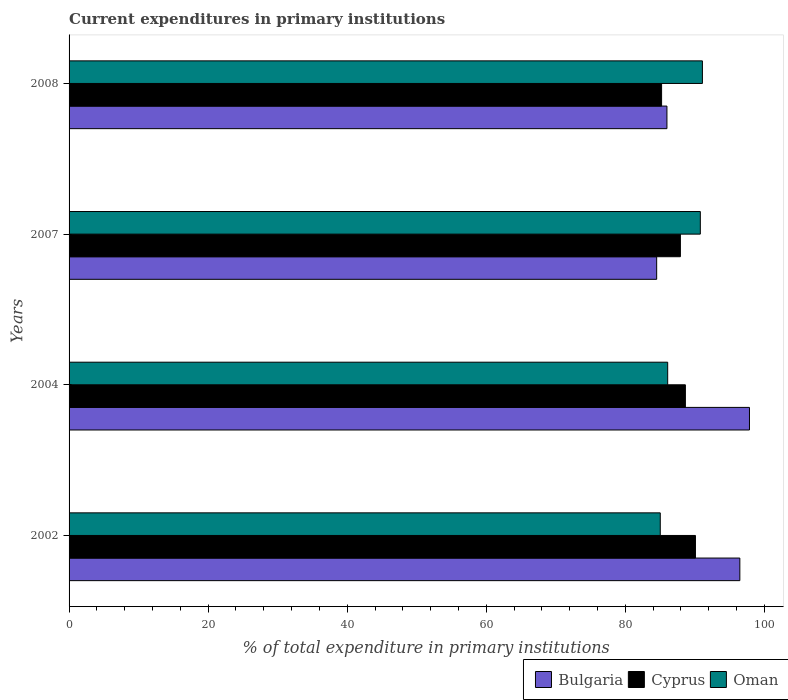How many groups of bars are there?
Your response must be concise. 4. Are the number of bars per tick equal to the number of legend labels?
Your answer should be very brief. Yes. What is the current expenditures in primary institutions in Bulgaria in 2007?
Provide a succinct answer. 84.51. Across all years, what is the maximum current expenditures in primary institutions in Bulgaria?
Provide a succinct answer. 97.85. Across all years, what is the minimum current expenditures in primary institutions in Oman?
Keep it short and to the point. 85.02. In which year was the current expenditures in primary institutions in Bulgaria maximum?
Your answer should be compact. 2004. What is the total current expenditures in primary institutions in Oman in the graph?
Give a very brief answer. 352.97. What is the difference between the current expenditures in primary institutions in Oman in 2002 and that in 2007?
Offer a terse response. -5.76. What is the difference between the current expenditures in primary institutions in Bulgaria in 2008 and the current expenditures in primary institutions in Oman in 2007?
Offer a terse response. -4.8. What is the average current expenditures in primary institutions in Bulgaria per year?
Your answer should be compact. 91.2. In the year 2004, what is the difference between the current expenditures in primary institutions in Bulgaria and current expenditures in primary institutions in Oman?
Keep it short and to the point. 11.76. In how many years, is the current expenditures in primary institutions in Oman greater than 12 %?
Provide a succinct answer. 4. What is the ratio of the current expenditures in primary institutions in Oman in 2002 to that in 2008?
Make the answer very short. 0.93. What is the difference between the highest and the second highest current expenditures in primary institutions in Cyprus?
Your answer should be compact. 1.45. What is the difference between the highest and the lowest current expenditures in primary institutions in Oman?
Your answer should be compact. 6.06. In how many years, is the current expenditures in primary institutions in Cyprus greater than the average current expenditures in primary institutions in Cyprus taken over all years?
Keep it short and to the point. 2. Is the sum of the current expenditures in primary institutions in Cyprus in 2004 and 2007 greater than the maximum current expenditures in primary institutions in Oman across all years?
Your answer should be compact. Yes. What does the 1st bar from the top in 2004 represents?
Offer a terse response. Oman. What does the 2nd bar from the bottom in 2008 represents?
Provide a succinct answer. Cyprus. Are all the bars in the graph horizontal?
Make the answer very short. Yes. How many years are there in the graph?
Make the answer very short. 4. Does the graph contain grids?
Provide a short and direct response. No. Where does the legend appear in the graph?
Ensure brevity in your answer.  Bottom right. How many legend labels are there?
Give a very brief answer. 3. What is the title of the graph?
Provide a short and direct response. Current expenditures in primary institutions. Does "Portugal" appear as one of the legend labels in the graph?
Offer a terse response. No. What is the label or title of the X-axis?
Keep it short and to the point. % of total expenditure in primary institutions. What is the label or title of the Y-axis?
Give a very brief answer. Years. What is the % of total expenditure in primary institutions of Bulgaria in 2002?
Your answer should be very brief. 96.47. What is the % of total expenditure in primary institutions in Cyprus in 2002?
Provide a short and direct response. 90.08. What is the % of total expenditure in primary institutions of Oman in 2002?
Ensure brevity in your answer.  85.02. What is the % of total expenditure in primary institutions of Bulgaria in 2004?
Ensure brevity in your answer.  97.85. What is the % of total expenditure in primary institutions of Cyprus in 2004?
Offer a terse response. 88.63. What is the % of total expenditure in primary institutions in Oman in 2004?
Make the answer very short. 86.09. What is the % of total expenditure in primary institutions in Bulgaria in 2007?
Your response must be concise. 84.51. What is the % of total expenditure in primary institutions of Cyprus in 2007?
Provide a succinct answer. 87.92. What is the % of total expenditure in primary institutions in Oman in 2007?
Make the answer very short. 90.78. What is the % of total expenditure in primary institutions of Bulgaria in 2008?
Your answer should be very brief. 85.98. What is the % of total expenditure in primary institutions of Cyprus in 2008?
Your response must be concise. 85.21. What is the % of total expenditure in primary institutions of Oman in 2008?
Ensure brevity in your answer.  91.08. Across all years, what is the maximum % of total expenditure in primary institutions in Bulgaria?
Give a very brief answer. 97.85. Across all years, what is the maximum % of total expenditure in primary institutions of Cyprus?
Ensure brevity in your answer.  90.08. Across all years, what is the maximum % of total expenditure in primary institutions in Oman?
Keep it short and to the point. 91.08. Across all years, what is the minimum % of total expenditure in primary institutions of Bulgaria?
Offer a very short reply. 84.51. Across all years, what is the minimum % of total expenditure in primary institutions of Cyprus?
Your answer should be very brief. 85.21. Across all years, what is the minimum % of total expenditure in primary institutions of Oman?
Your answer should be compact. 85.02. What is the total % of total expenditure in primary institutions of Bulgaria in the graph?
Give a very brief answer. 364.8. What is the total % of total expenditure in primary institutions of Cyprus in the graph?
Your answer should be compact. 351.85. What is the total % of total expenditure in primary institutions in Oman in the graph?
Make the answer very short. 352.97. What is the difference between the % of total expenditure in primary institutions in Bulgaria in 2002 and that in 2004?
Keep it short and to the point. -1.38. What is the difference between the % of total expenditure in primary institutions in Cyprus in 2002 and that in 2004?
Provide a short and direct response. 1.45. What is the difference between the % of total expenditure in primary institutions of Oman in 2002 and that in 2004?
Offer a terse response. -1.07. What is the difference between the % of total expenditure in primary institutions in Bulgaria in 2002 and that in 2007?
Make the answer very short. 11.96. What is the difference between the % of total expenditure in primary institutions in Cyprus in 2002 and that in 2007?
Provide a succinct answer. 2.17. What is the difference between the % of total expenditure in primary institutions in Oman in 2002 and that in 2007?
Keep it short and to the point. -5.76. What is the difference between the % of total expenditure in primary institutions in Bulgaria in 2002 and that in 2008?
Your answer should be very brief. 10.49. What is the difference between the % of total expenditure in primary institutions of Cyprus in 2002 and that in 2008?
Keep it short and to the point. 4.87. What is the difference between the % of total expenditure in primary institutions of Oman in 2002 and that in 2008?
Ensure brevity in your answer.  -6.06. What is the difference between the % of total expenditure in primary institutions in Bulgaria in 2004 and that in 2007?
Provide a short and direct response. 13.35. What is the difference between the % of total expenditure in primary institutions of Cyprus in 2004 and that in 2007?
Provide a succinct answer. 0.72. What is the difference between the % of total expenditure in primary institutions of Oman in 2004 and that in 2007?
Provide a short and direct response. -4.69. What is the difference between the % of total expenditure in primary institutions of Bulgaria in 2004 and that in 2008?
Provide a succinct answer. 11.87. What is the difference between the % of total expenditure in primary institutions of Cyprus in 2004 and that in 2008?
Ensure brevity in your answer.  3.42. What is the difference between the % of total expenditure in primary institutions in Oman in 2004 and that in 2008?
Your answer should be very brief. -4.99. What is the difference between the % of total expenditure in primary institutions in Bulgaria in 2007 and that in 2008?
Provide a succinct answer. -1.48. What is the difference between the % of total expenditure in primary institutions of Cyprus in 2007 and that in 2008?
Provide a succinct answer. 2.7. What is the difference between the % of total expenditure in primary institutions in Oman in 2007 and that in 2008?
Offer a terse response. -0.3. What is the difference between the % of total expenditure in primary institutions of Bulgaria in 2002 and the % of total expenditure in primary institutions of Cyprus in 2004?
Provide a short and direct response. 7.83. What is the difference between the % of total expenditure in primary institutions of Bulgaria in 2002 and the % of total expenditure in primary institutions of Oman in 2004?
Your answer should be compact. 10.38. What is the difference between the % of total expenditure in primary institutions of Cyprus in 2002 and the % of total expenditure in primary institutions of Oman in 2004?
Give a very brief answer. 3.99. What is the difference between the % of total expenditure in primary institutions in Bulgaria in 2002 and the % of total expenditure in primary institutions in Cyprus in 2007?
Provide a short and direct response. 8.55. What is the difference between the % of total expenditure in primary institutions in Bulgaria in 2002 and the % of total expenditure in primary institutions in Oman in 2007?
Your answer should be compact. 5.68. What is the difference between the % of total expenditure in primary institutions in Cyprus in 2002 and the % of total expenditure in primary institutions in Oman in 2007?
Offer a terse response. -0.7. What is the difference between the % of total expenditure in primary institutions of Bulgaria in 2002 and the % of total expenditure in primary institutions of Cyprus in 2008?
Provide a short and direct response. 11.25. What is the difference between the % of total expenditure in primary institutions in Bulgaria in 2002 and the % of total expenditure in primary institutions in Oman in 2008?
Make the answer very short. 5.38. What is the difference between the % of total expenditure in primary institutions in Cyprus in 2002 and the % of total expenditure in primary institutions in Oman in 2008?
Provide a short and direct response. -1. What is the difference between the % of total expenditure in primary institutions in Bulgaria in 2004 and the % of total expenditure in primary institutions in Cyprus in 2007?
Ensure brevity in your answer.  9.93. What is the difference between the % of total expenditure in primary institutions of Bulgaria in 2004 and the % of total expenditure in primary institutions of Oman in 2007?
Your answer should be compact. 7.07. What is the difference between the % of total expenditure in primary institutions of Cyprus in 2004 and the % of total expenditure in primary institutions of Oman in 2007?
Your answer should be very brief. -2.15. What is the difference between the % of total expenditure in primary institutions of Bulgaria in 2004 and the % of total expenditure in primary institutions of Cyprus in 2008?
Keep it short and to the point. 12.64. What is the difference between the % of total expenditure in primary institutions in Bulgaria in 2004 and the % of total expenditure in primary institutions in Oman in 2008?
Make the answer very short. 6.77. What is the difference between the % of total expenditure in primary institutions of Cyprus in 2004 and the % of total expenditure in primary institutions of Oman in 2008?
Your response must be concise. -2.45. What is the difference between the % of total expenditure in primary institutions in Bulgaria in 2007 and the % of total expenditure in primary institutions in Cyprus in 2008?
Offer a very short reply. -0.71. What is the difference between the % of total expenditure in primary institutions in Bulgaria in 2007 and the % of total expenditure in primary institutions in Oman in 2008?
Your answer should be compact. -6.58. What is the difference between the % of total expenditure in primary institutions of Cyprus in 2007 and the % of total expenditure in primary institutions of Oman in 2008?
Give a very brief answer. -3.17. What is the average % of total expenditure in primary institutions of Bulgaria per year?
Offer a very short reply. 91.2. What is the average % of total expenditure in primary institutions of Cyprus per year?
Offer a very short reply. 87.96. What is the average % of total expenditure in primary institutions in Oman per year?
Ensure brevity in your answer.  88.24. In the year 2002, what is the difference between the % of total expenditure in primary institutions in Bulgaria and % of total expenditure in primary institutions in Cyprus?
Your answer should be very brief. 6.38. In the year 2002, what is the difference between the % of total expenditure in primary institutions of Bulgaria and % of total expenditure in primary institutions of Oman?
Ensure brevity in your answer.  11.44. In the year 2002, what is the difference between the % of total expenditure in primary institutions in Cyprus and % of total expenditure in primary institutions in Oman?
Your answer should be very brief. 5.06. In the year 2004, what is the difference between the % of total expenditure in primary institutions in Bulgaria and % of total expenditure in primary institutions in Cyprus?
Your answer should be very brief. 9.22. In the year 2004, what is the difference between the % of total expenditure in primary institutions of Bulgaria and % of total expenditure in primary institutions of Oman?
Make the answer very short. 11.76. In the year 2004, what is the difference between the % of total expenditure in primary institutions in Cyprus and % of total expenditure in primary institutions in Oman?
Provide a short and direct response. 2.55. In the year 2007, what is the difference between the % of total expenditure in primary institutions in Bulgaria and % of total expenditure in primary institutions in Cyprus?
Give a very brief answer. -3.41. In the year 2007, what is the difference between the % of total expenditure in primary institutions of Bulgaria and % of total expenditure in primary institutions of Oman?
Ensure brevity in your answer.  -6.28. In the year 2007, what is the difference between the % of total expenditure in primary institutions in Cyprus and % of total expenditure in primary institutions in Oman?
Your response must be concise. -2.87. In the year 2008, what is the difference between the % of total expenditure in primary institutions in Bulgaria and % of total expenditure in primary institutions in Cyprus?
Keep it short and to the point. 0.77. In the year 2008, what is the difference between the % of total expenditure in primary institutions in Bulgaria and % of total expenditure in primary institutions in Oman?
Your answer should be compact. -5.1. In the year 2008, what is the difference between the % of total expenditure in primary institutions in Cyprus and % of total expenditure in primary institutions in Oman?
Give a very brief answer. -5.87. What is the ratio of the % of total expenditure in primary institutions of Bulgaria in 2002 to that in 2004?
Your response must be concise. 0.99. What is the ratio of the % of total expenditure in primary institutions in Cyprus in 2002 to that in 2004?
Offer a very short reply. 1.02. What is the ratio of the % of total expenditure in primary institutions in Oman in 2002 to that in 2004?
Provide a succinct answer. 0.99. What is the ratio of the % of total expenditure in primary institutions of Bulgaria in 2002 to that in 2007?
Give a very brief answer. 1.14. What is the ratio of the % of total expenditure in primary institutions of Cyprus in 2002 to that in 2007?
Make the answer very short. 1.02. What is the ratio of the % of total expenditure in primary institutions of Oman in 2002 to that in 2007?
Make the answer very short. 0.94. What is the ratio of the % of total expenditure in primary institutions in Bulgaria in 2002 to that in 2008?
Your answer should be very brief. 1.12. What is the ratio of the % of total expenditure in primary institutions in Cyprus in 2002 to that in 2008?
Provide a succinct answer. 1.06. What is the ratio of the % of total expenditure in primary institutions in Oman in 2002 to that in 2008?
Keep it short and to the point. 0.93. What is the ratio of the % of total expenditure in primary institutions in Bulgaria in 2004 to that in 2007?
Offer a terse response. 1.16. What is the ratio of the % of total expenditure in primary institutions in Cyprus in 2004 to that in 2007?
Your answer should be compact. 1.01. What is the ratio of the % of total expenditure in primary institutions in Oman in 2004 to that in 2007?
Make the answer very short. 0.95. What is the ratio of the % of total expenditure in primary institutions of Bulgaria in 2004 to that in 2008?
Offer a very short reply. 1.14. What is the ratio of the % of total expenditure in primary institutions of Cyprus in 2004 to that in 2008?
Offer a very short reply. 1.04. What is the ratio of the % of total expenditure in primary institutions of Oman in 2004 to that in 2008?
Your answer should be very brief. 0.95. What is the ratio of the % of total expenditure in primary institutions of Bulgaria in 2007 to that in 2008?
Your answer should be compact. 0.98. What is the ratio of the % of total expenditure in primary institutions in Cyprus in 2007 to that in 2008?
Offer a very short reply. 1.03. What is the difference between the highest and the second highest % of total expenditure in primary institutions in Bulgaria?
Make the answer very short. 1.38. What is the difference between the highest and the second highest % of total expenditure in primary institutions in Cyprus?
Give a very brief answer. 1.45. What is the difference between the highest and the second highest % of total expenditure in primary institutions of Oman?
Keep it short and to the point. 0.3. What is the difference between the highest and the lowest % of total expenditure in primary institutions of Bulgaria?
Offer a terse response. 13.35. What is the difference between the highest and the lowest % of total expenditure in primary institutions of Cyprus?
Give a very brief answer. 4.87. What is the difference between the highest and the lowest % of total expenditure in primary institutions in Oman?
Make the answer very short. 6.06. 